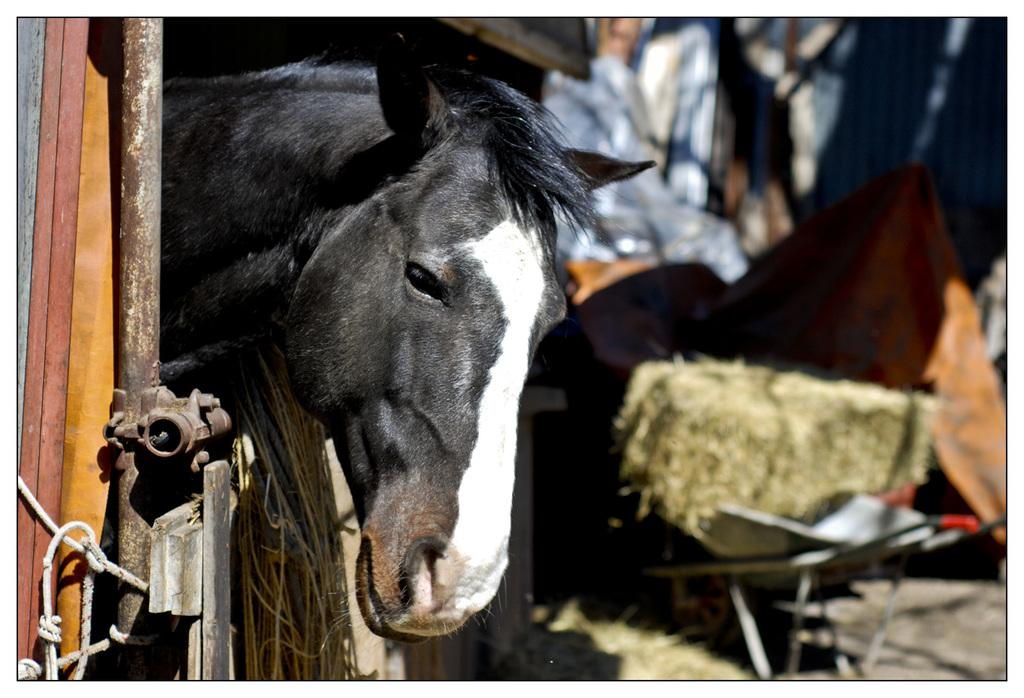Where was the image likely taken? The image was likely clicked outside. What animal can be seen on the left side of the image? There is a horse on the left side of the image. What type of objects are present in the image? There are metal objects in the image. What is used to control or guide the horse in the image? There is a rope in the image. What can be seen on the right side of the image? There are many other objects on the right side of the image. How many chickens are present in the image? There are no chickens present in the image. What type of store can be seen in the background of the image? There is no store visible in the image. 